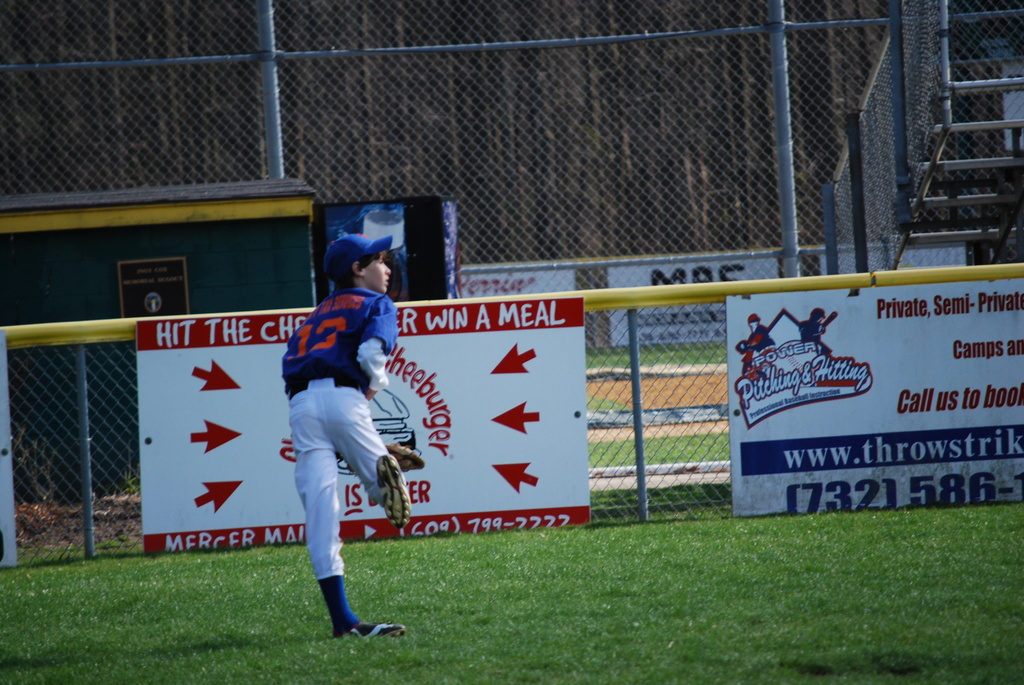Provide a one-sentence caption for the provided image. A baseball player, dressed in a blue uniform, skillfully catches a fly ball on a sunny day, against a backdrop of vibrant advertising banners promoting local sports training services. 